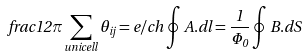<formula> <loc_0><loc_0><loc_500><loc_500>f r a c { 1 } { 2 \pi } \sum _ { u n i c e l l } \theta _ { i j } = e / c h \oint { A } . { d l } = \frac { 1 } { \Phi _ { 0 } } \oint { B } . { d S }</formula> 